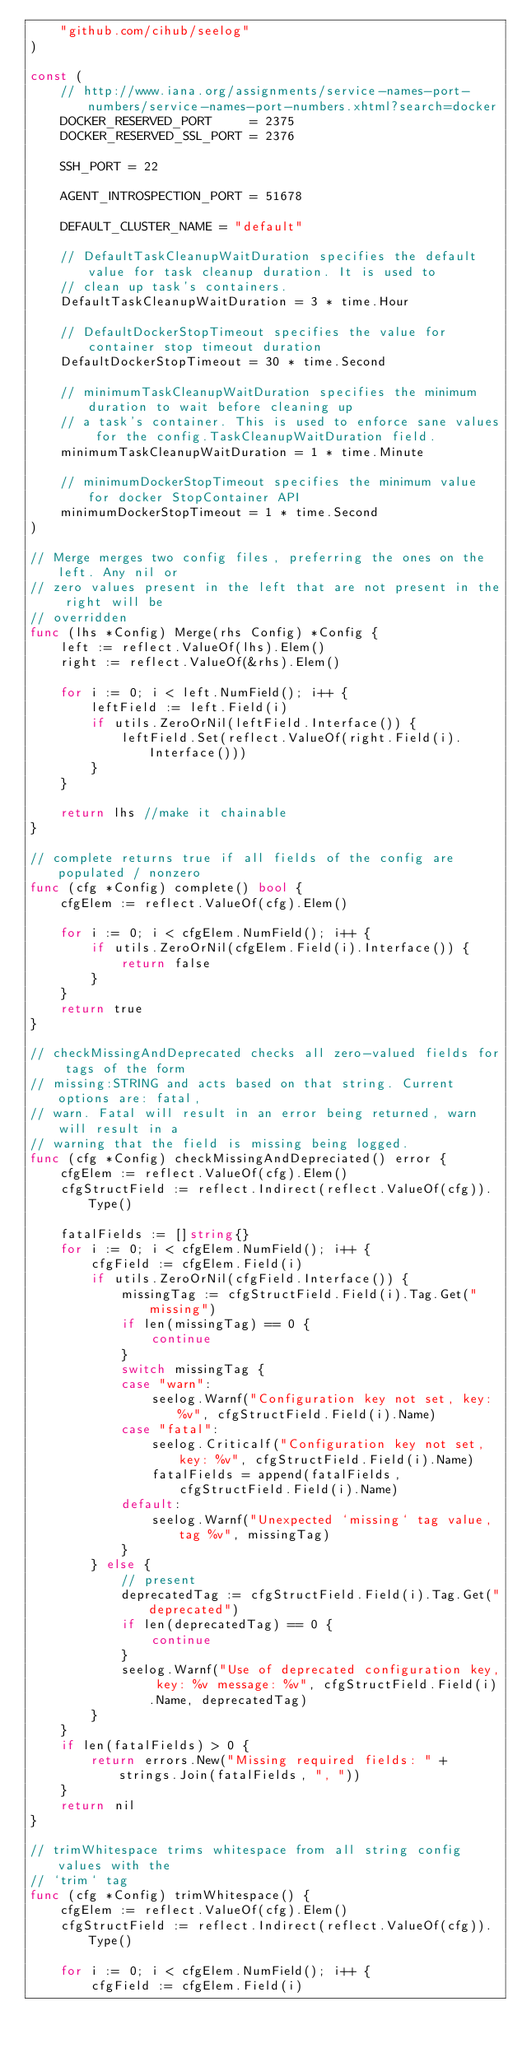<code> <loc_0><loc_0><loc_500><loc_500><_Go_>	"github.com/cihub/seelog"
)

const (
	// http://www.iana.org/assignments/service-names-port-numbers/service-names-port-numbers.xhtml?search=docker
	DOCKER_RESERVED_PORT     = 2375
	DOCKER_RESERVED_SSL_PORT = 2376

	SSH_PORT = 22

	AGENT_INTROSPECTION_PORT = 51678

	DEFAULT_CLUSTER_NAME = "default"

	// DefaultTaskCleanupWaitDuration specifies the default value for task cleanup duration. It is used to
	// clean up task's containers.
	DefaultTaskCleanupWaitDuration = 3 * time.Hour

	// DefaultDockerStopTimeout specifies the value for container stop timeout duration
	DefaultDockerStopTimeout = 30 * time.Second

	// minimumTaskCleanupWaitDuration specifies the minimum duration to wait before cleaning up
	// a task's container. This is used to enforce sane values for the config.TaskCleanupWaitDuration field.
	minimumTaskCleanupWaitDuration = 1 * time.Minute

	// minimumDockerStopTimeout specifies the minimum value for docker StopContainer API
	minimumDockerStopTimeout = 1 * time.Second
)

// Merge merges two config files, preferring the ones on the left. Any nil or
// zero values present in the left that are not present in the right will be
// overridden
func (lhs *Config) Merge(rhs Config) *Config {
	left := reflect.ValueOf(lhs).Elem()
	right := reflect.ValueOf(&rhs).Elem()

	for i := 0; i < left.NumField(); i++ {
		leftField := left.Field(i)
		if utils.ZeroOrNil(leftField.Interface()) {
			leftField.Set(reflect.ValueOf(right.Field(i).Interface()))
		}
	}

	return lhs //make it chainable
}

// complete returns true if all fields of the config are populated / nonzero
func (cfg *Config) complete() bool {
	cfgElem := reflect.ValueOf(cfg).Elem()

	for i := 0; i < cfgElem.NumField(); i++ {
		if utils.ZeroOrNil(cfgElem.Field(i).Interface()) {
			return false
		}
	}
	return true
}

// checkMissingAndDeprecated checks all zero-valued fields for tags of the form
// missing:STRING and acts based on that string. Current options are: fatal,
// warn. Fatal will result in an error being returned, warn will result in a
// warning that the field is missing being logged.
func (cfg *Config) checkMissingAndDepreciated() error {
	cfgElem := reflect.ValueOf(cfg).Elem()
	cfgStructField := reflect.Indirect(reflect.ValueOf(cfg)).Type()

	fatalFields := []string{}
	for i := 0; i < cfgElem.NumField(); i++ {
		cfgField := cfgElem.Field(i)
		if utils.ZeroOrNil(cfgField.Interface()) {
			missingTag := cfgStructField.Field(i).Tag.Get("missing")
			if len(missingTag) == 0 {
				continue
			}
			switch missingTag {
			case "warn":
				seelog.Warnf("Configuration key not set, key: %v", cfgStructField.Field(i).Name)
			case "fatal":
				seelog.Criticalf("Configuration key not set, key: %v", cfgStructField.Field(i).Name)
				fatalFields = append(fatalFields, cfgStructField.Field(i).Name)
			default:
				seelog.Warnf("Unexpected `missing` tag value, tag %v", missingTag)
			}
		} else {
			// present
			deprecatedTag := cfgStructField.Field(i).Tag.Get("deprecated")
			if len(deprecatedTag) == 0 {
				continue
			}
			seelog.Warnf("Use of deprecated configuration key, key: %v message: %v", cfgStructField.Field(i).Name, deprecatedTag)
		}
	}
	if len(fatalFields) > 0 {
		return errors.New("Missing required fields: " + strings.Join(fatalFields, ", "))
	}
	return nil
}

// trimWhitespace trims whitespace from all string config values with the
// `trim` tag
func (cfg *Config) trimWhitespace() {
	cfgElem := reflect.ValueOf(cfg).Elem()
	cfgStructField := reflect.Indirect(reflect.ValueOf(cfg)).Type()

	for i := 0; i < cfgElem.NumField(); i++ {
		cfgField := cfgElem.Field(i)</code> 